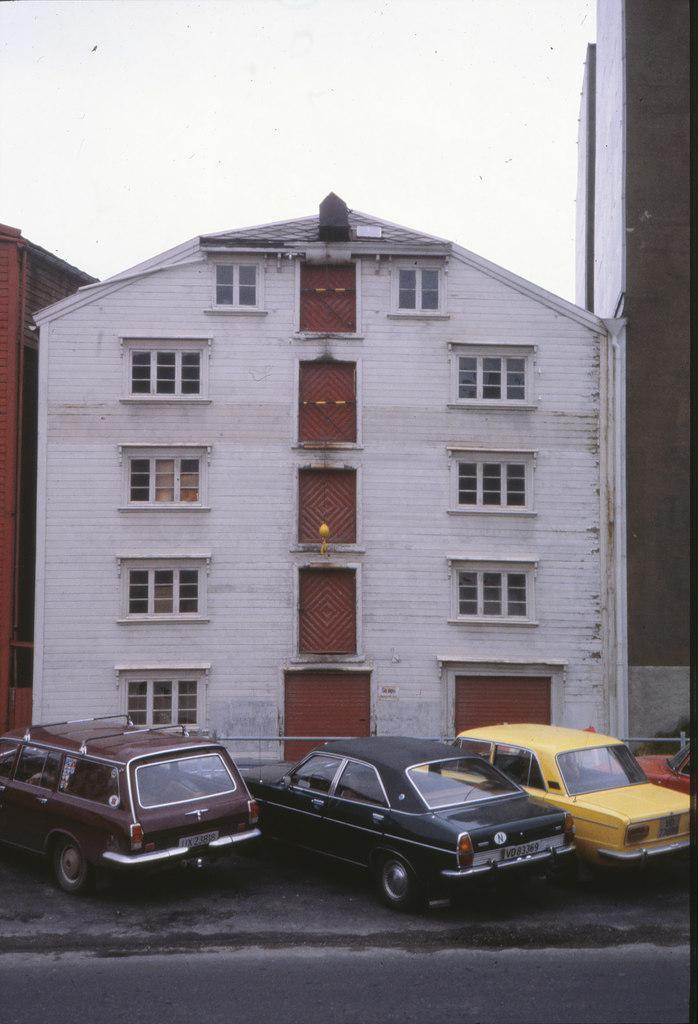How would you summarize this image in a sentence or two? In this image I can see the ground, few vehicles on the ground and few buildings. In the background I can see the sky. 